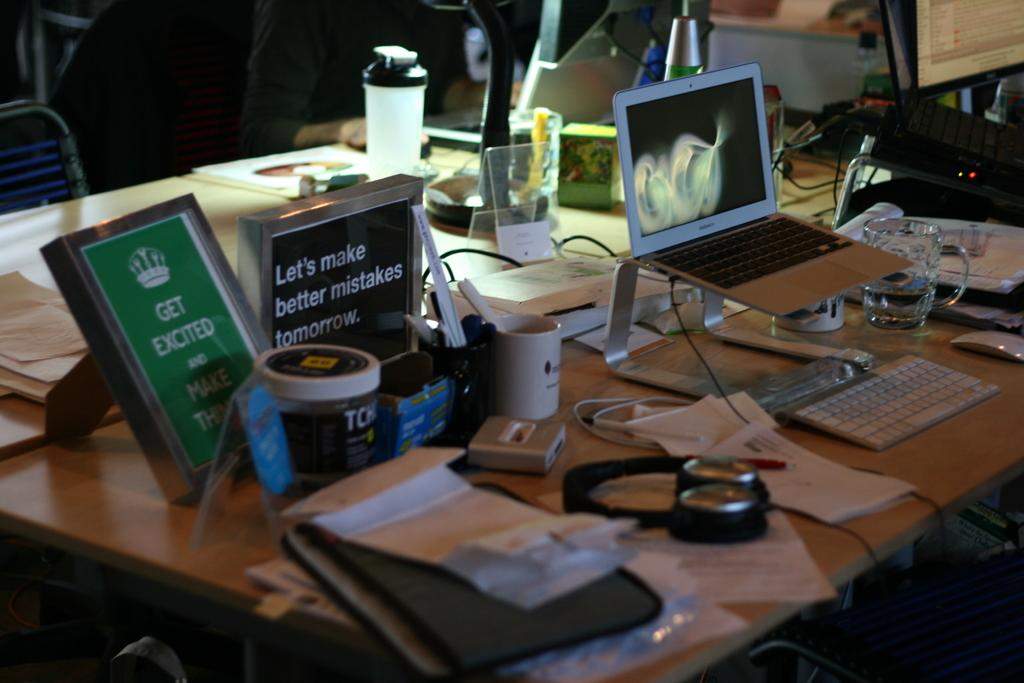What type of setting is depicted in the image? The image shows an inside view of a room. Can you describe the person in the room? There is a person sitting in the room. What is the person sitting in front of? The person is sitting in front of a table. What items can be seen on the table? The table contains bottles, cups, glasses, laptops, headsets, and papers. What type of nerve can be seen connecting the person to the table in the image? There is no nerve connecting the person to the table in the image. How does the person's nerve affect the items on the table? The image does not show any nerve connecting the person to the table, so it cannot be determined how it would affect the items on the table. 